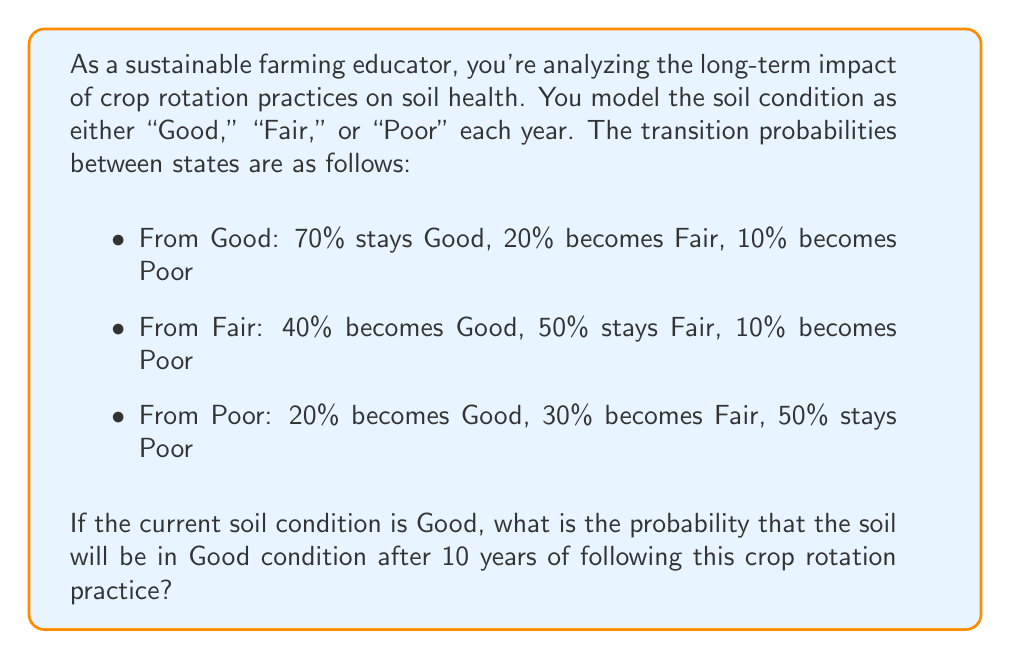Solve this math problem. To solve this problem, we'll use Markov chains:

1) First, let's define our transition matrix P:

   $$P = \begin{bmatrix}
   0.7 & 0.2 & 0.1 \\
   0.4 & 0.5 & 0.1 \\
   0.2 & 0.3 & 0.5
   \end{bmatrix}$$

2) We need to calculate $P^{10}$, as we're interested in the state after 10 years.

3) We can use the eigendecomposition method to calculate $P^{10}$ efficiently:

   $P = QDQ^{-1}$, where D is a diagonal matrix of eigenvalues and Q is a matrix of eigenvectors.

4) Calculate eigenvalues and eigenvectors (using a computer algebra system):

   Eigenvalues: $\lambda_1 = 1$, $\lambda_2 \approx 0.5858$, $\lambda_3 \approx 0.1142$

   $$Q \approx \begin{bmatrix}
   0.6124 & -0.7071 & -0.3536 \\
   0.5249 & 0.0000 & 0.7071 \\
   0.5912 & 0.7071 & -0.3536
   \end{bmatrix}$$

5) Form the diagonal matrix D:

   $$D = \begin{bmatrix}
   1 & 0 & 0 \\
   0 & 0.5858 & 0 \\
   0 & 0 & 0.1142
   \end{bmatrix}$$

6) Calculate $D^{10}$:

   $$D^{10} = \begin{bmatrix}
   1 & 0 & 0 \\
   0 & 0.0016 & 0 \\
   0 & 0 & 0.0000
   \end{bmatrix}$$

7) Calculate $P^{10} = QD^{10}Q^{-1}$:

   $$P^{10} \approx \begin{bmatrix}
   0.5755 & 0.2830 & 0.1415 \\
   0.5660 & 0.2877 & 0.1462 \\
   0.5472 & 0.2972 & 0.1557
   \end{bmatrix}$$

8) The probability of being in the Good state after 10 years, starting from the Good state, is the element in the first row and first column of $P^{10}$.

Therefore, the probability is approximately 0.5755 or 57.55%.
Answer: 0.5755 